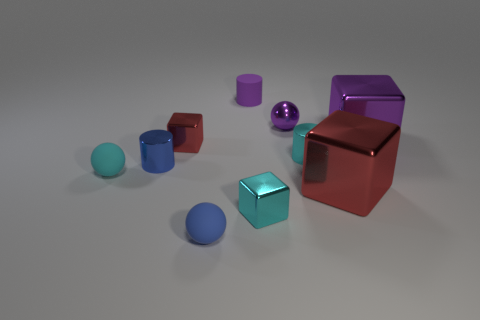Subtract all gray blocks. Subtract all blue spheres. How many blocks are left? 4 Subtract all cubes. How many objects are left? 6 Add 3 blue objects. How many blue objects are left? 5 Add 9 cyan metal cubes. How many cyan metal cubes exist? 10 Subtract 0 yellow blocks. How many objects are left? 10 Subtract all small red shiny things. Subtract all big brown cubes. How many objects are left? 9 